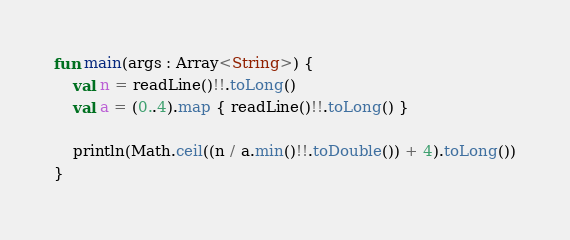<code> <loc_0><loc_0><loc_500><loc_500><_Kotlin_>
fun main(args : Array<String>) {
    val n = readLine()!!.toLong()
    val a = (0..4).map { readLine()!!.toLong() }

    println(Math.ceil((n / a.min()!!.toDouble()) + 4).toLong())
}</code> 